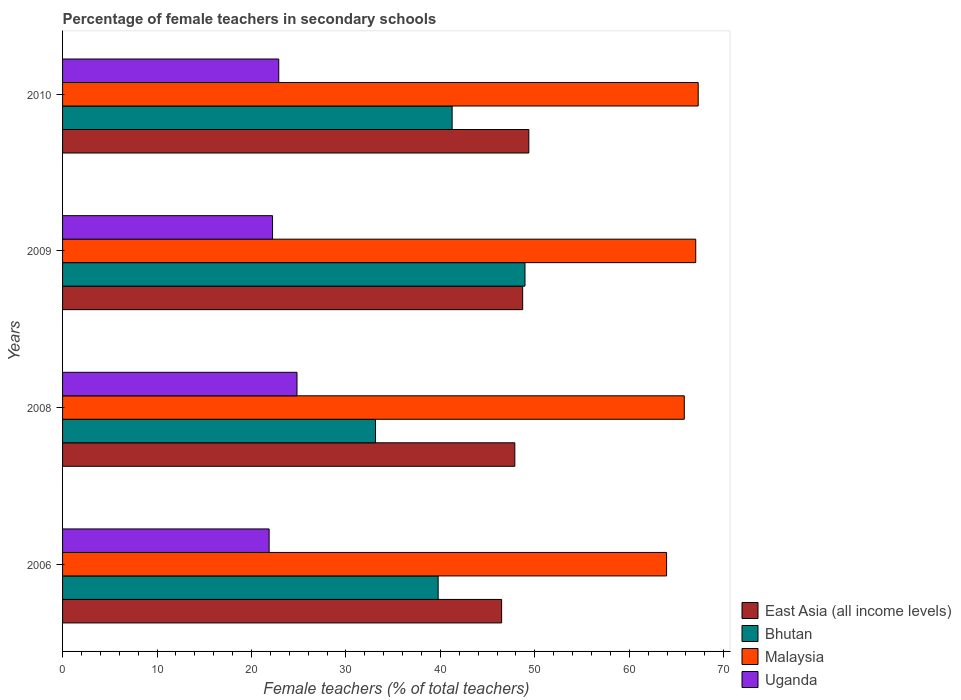Are the number of bars on each tick of the Y-axis equal?
Keep it short and to the point. Yes. What is the label of the 4th group of bars from the top?
Your response must be concise. 2006. What is the percentage of female teachers in Bhutan in 2006?
Provide a short and direct response. 39.77. Across all years, what is the maximum percentage of female teachers in East Asia (all income levels)?
Offer a terse response. 49.37. Across all years, what is the minimum percentage of female teachers in Malaysia?
Your answer should be compact. 63.95. In which year was the percentage of female teachers in Bhutan minimum?
Make the answer very short. 2008. What is the total percentage of female teachers in Bhutan in the graph?
Your answer should be very brief. 163.11. What is the difference between the percentage of female teachers in Bhutan in 2009 and that in 2010?
Provide a short and direct response. 7.71. What is the difference between the percentage of female teachers in Uganda in 2006 and the percentage of female teachers in Bhutan in 2008?
Provide a short and direct response. -11.27. What is the average percentage of female teachers in Bhutan per year?
Give a very brief answer. 40.78. In the year 2008, what is the difference between the percentage of female teachers in East Asia (all income levels) and percentage of female teachers in Bhutan?
Your answer should be compact. 14.75. In how many years, is the percentage of female teachers in Bhutan greater than 2 %?
Your answer should be compact. 4. What is the ratio of the percentage of female teachers in Uganda in 2006 to that in 2010?
Your answer should be compact. 0.96. What is the difference between the highest and the second highest percentage of female teachers in Malaysia?
Offer a terse response. 0.26. What is the difference between the highest and the lowest percentage of female teachers in Bhutan?
Your response must be concise. 15.82. In how many years, is the percentage of female teachers in Uganda greater than the average percentage of female teachers in Uganda taken over all years?
Your answer should be very brief. 1. What does the 4th bar from the top in 2010 represents?
Your answer should be compact. East Asia (all income levels). What does the 2nd bar from the bottom in 2006 represents?
Provide a succinct answer. Bhutan. Is it the case that in every year, the sum of the percentage of female teachers in Malaysia and percentage of female teachers in Uganda is greater than the percentage of female teachers in East Asia (all income levels)?
Provide a succinct answer. Yes. How many bars are there?
Your answer should be very brief. 16. How many years are there in the graph?
Your answer should be very brief. 4. Does the graph contain grids?
Provide a succinct answer. No. Where does the legend appear in the graph?
Keep it short and to the point. Bottom right. How are the legend labels stacked?
Provide a short and direct response. Vertical. What is the title of the graph?
Make the answer very short. Percentage of female teachers in secondary schools. Does "Japan" appear as one of the legend labels in the graph?
Ensure brevity in your answer.  No. What is the label or title of the X-axis?
Your answer should be very brief. Female teachers (% of total teachers). What is the label or title of the Y-axis?
Your response must be concise. Years. What is the Female teachers (% of total teachers) in East Asia (all income levels) in 2006?
Provide a succinct answer. 46.49. What is the Female teachers (% of total teachers) in Bhutan in 2006?
Your answer should be compact. 39.77. What is the Female teachers (% of total teachers) of Malaysia in 2006?
Your response must be concise. 63.95. What is the Female teachers (% of total teachers) in Uganda in 2006?
Offer a terse response. 21.87. What is the Female teachers (% of total teachers) of East Asia (all income levels) in 2008?
Make the answer very short. 47.88. What is the Female teachers (% of total teachers) in Bhutan in 2008?
Your response must be concise. 33.14. What is the Female teachers (% of total teachers) in Malaysia in 2008?
Make the answer very short. 65.83. What is the Female teachers (% of total teachers) of Uganda in 2008?
Offer a very short reply. 24.82. What is the Female teachers (% of total teachers) of East Asia (all income levels) in 2009?
Your response must be concise. 48.71. What is the Female teachers (% of total teachers) of Bhutan in 2009?
Give a very brief answer. 48.96. What is the Female teachers (% of total teachers) in Malaysia in 2009?
Ensure brevity in your answer.  67.04. What is the Female teachers (% of total teachers) in Uganda in 2009?
Provide a short and direct response. 22.23. What is the Female teachers (% of total teachers) in East Asia (all income levels) in 2010?
Your answer should be compact. 49.37. What is the Female teachers (% of total teachers) in Bhutan in 2010?
Offer a terse response. 41.25. What is the Female teachers (% of total teachers) in Malaysia in 2010?
Provide a short and direct response. 67.3. What is the Female teachers (% of total teachers) in Uganda in 2010?
Your answer should be compact. 22.89. Across all years, what is the maximum Female teachers (% of total teachers) in East Asia (all income levels)?
Keep it short and to the point. 49.37. Across all years, what is the maximum Female teachers (% of total teachers) of Bhutan?
Keep it short and to the point. 48.96. Across all years, what is the maximum Female teachers (% of total teachers) of Malaysia?
Give a very brief answer. 67.3. Across all years, what is the maximum Female teachers (% of total teachers) in Uganda?
Provide a short and direct response. 24.82. Across all years, what is the minimum Female teachers (% of total teachers) of East Asia (all income levels)?
Your answer should be compact. 46.49. Across all years, what is the minimum Female teachers (% of total teachers) of Bhutan?
Give a very brief answer. 33.14. Across all years, what is the minimum Female teachers (% of total teachers) of Malaysia?
Your answer should be compact. 63.95. Across all years, what is the minimum Female teachers (% of total teachers) in Uganda?
Provide a short and direct response. 21.87. What is the total Female teachers (% of total teachers) in East Asia (all income levels) in the graph?
Your answer should be compact. 192.45. What is the total Female teachers (% of total teachers) in Bhutan in the graph?
Offer a very short reply. 163.11. What is the total Female teachers (% of total teachers) of Malaysia in the graph?
Your answer should be compact. 264.12. What is the total Female teachers (% of total teachers) in Uganda in the graph?
Your answer should be very brief. 91.81. What is the difference between the Female teachers (% of total teachers) in East Asia (all income levels) in 2006 and that in 2008?
Keep it short and to the point. -1.4. What is the difference between the Female teachers (% of total teachers) in Bhutan in 2006 and that in 2008?
Keep it short and to the point. 6.63. What is the difference between the Female teachers (% of total teachers) of Malaysia in 2006 and that in 2008?
Make the answer very short. -1.87. What is the difference between the Female teachers (% of total teachers) in Uganda in 2006 and that in 2008?
Ensure brevity in your answer.  -2.95. What is the difference between the Female teachers (% of total teachers) in East Asia (all income levels) in 2006 and that in 2009?
Ensure brevity in your answer.  -2.23. What is the difference between the Female teachers (% of total teachers) in Bhutan in 2006 and that in 2009?
Provide a succinct answer. -9.19. What is the difference between the Female teachers (% of total teachers) in Malaysia in 2006 and that in 2009?
Provide a succinct answer. -3.09. What is the difference between the Female teachers (% of total teachers) in Uganda in 2006 and that in 2009?
Provide a succinct answer. -0.36. What is the difference between the Female teachers (% of total teachers) in East Asia (all income levels) in 2006 and that in 2010?
Offer a terse response. -2.88. What is the difference between the Female teachers (% of total teachers) of Bhutan in 2006 and that in 2010?
Ensure brevity in your answer.  -1.48. What is the difference between the Female teachers (% of total teachers) of Malaysia in 2006 and that in 2010?
Give a very brief answer. -3.35. What is the difference between the Female teachers (% of total teachers) of Uganda in 2006 and that in 2010?
Give a very brief answer. -1.02. What is the difference between the Female teachers (% of total teachers) of East Asia (all income levels) in 2008 and that in 2009?
Provide a short and direct response. -0.83. What is the difference between the Female teachers (% of total teachers) of Bhutan in 2008 and that in 2009?
Provide a short and direct response. -15.82. What is the difference between the Female teachers (% of total teachers) in Malaysia in 2008 and that in 2009?
Provide a succinct answer. -1.21. What is the difference between the Female teachers (% of total teachers) of Uganda in 2008 and that in 2009?
Your answer should be very brief. 2.59. What is the difference between the Female teachers (% of total teachers) in East Asia (all income levels) in 2008 and that in 2010?
Ensure brevity in your answer.  -1.48. What is the difference between the Female teachers (% of total teachers) of Bhutan in 2008 and that in 2010?
Your answer should be very brief. -8.11. What is the difference between the Female teachers (% of total teachers) of Malaysia in 2008 and that in 2010?
Offer a terse response. -1.47. What is the difference between the Female teachers (% of total teachers) of Uganda in 2008 and that in 2010?
Your answer should be compact. 1.93. What is the difference between the Female teachers (% of total teachers) in East Asia (all income levels) in 2009 and that in 2010?
Offer a very short reply. -0.65. What is the difference between the Female teachers (% of total teachers) in Bhutan in 2009 and that in 2010?
Provide a succinct answer. 7.71. What is the difference between the Female teachers (% of total teachers) of Malaysia in 2009 and that in 2010?
Ensure brevity in your answer.  -0.26. What is the difference between the Female teachers (% of total teachers) in Uganda in 2009 and that in 2010?
Offer a very short reply. -0.66. What is the difference between the Female teachers (% of total teachers) of East Asia (all income levels) in 2006 and the Female teachers (% of total teachers) of Bhutan in 2008?
Ensure brevity in your answer.  13.35. What is the difference between the Female teachers (% of total teachers) in East Asia (all income levels) in 2006 and the Female teachers (% of total teachers) in Malaysia in 2008?
Make the answer very short. -19.34. What is the difference between the Female teachers (% of total teachers) of East Asia (all income levels) in 2006 and the Female teachers (% of total teachers) of Uganda in 2008?
Your response must be concise. 21.67. What is the difference between the Female teachers (% of total teachers) in Bhutan in 2006 and the Female teachers (% of total teachers) in Malaysia in 2008?
Offer a very short reply. -26.06. What is the difference between the Female teachers (% of total teachers) of Bhutan in 2006 and the Female teachers (% of total teachers) of Uganda in 2008?
Give a very brief answer. 14.95. What is the difference between the Female teachers (% of total teachers) of Malaysia in 2006 and the Female teachers (% of total teachers) of Uganda in 2008?
Your response must be concise. 39.13. What is the difference between the Female teachers (% of total teachers) in East Asia (all income levels) in 2006 and the Female teachers (% of total teachers) in Bhutan in 2009?
Provide a short and direct response. -2.47. What is the difference between the Female teachers (% of total teachers) of East Asia (all income levels) in 2006 and the Female teachers (% of total teachers) of Malaysia in 2009?
Offer a very short reply. -20.55. What is the difference between the Female teachers (% of total teachers) in East Asia (all income levels) in 2006 and the Female teachers (% of total teachers) in Uganda in 2009?
Your answer should be very brief. 24.25. What is the difference between the Female teachers (% of total teachers) in Bhutan in 2006 and the Female teachers (% of total teachers) in Malaysia in 2009?
Keep it short and to the point. -27.27. What is the difference between the Female teachers (% of total teachers) of Bhutan in 2006 and the Female teachers (% of total teachers) of Uganda in 2009?
Your response must be concise. 17.53. What is the difference between the Female teachers (% of total teachers) of Malaysia in 2006 and the Female teachers (% of total teachers) of Uganda in 2009?
Make the answer very short. 41.72. What is the difference between the Female teachers (% of total teachers) in East Asia (all income levels) in 2006 and the Female teachers (% of total teachers) in Bhutan in 2010?
Ensure brevity in your answer.  5.24. What is the difference between the Female teachers (% of total teachers) of East Asia (all income levels) in 2006 and the Female teachers (% of total teachers) of Malaysia in 2010?
Keep it short and to the point. -20.81. What is the difference between the Female teachers (% of total teachers) of East Asia (all income levels) in 2006 and the Female teachers (% of total teachers) of Uganda in 2010?
Keep it short and to the point. 23.6. What is the difference between the Female teachers (% of total teachers) of Bhutan in 2006 and the Female teachers (% of total teachers) of Malaysia in 2010?
Offer a very short reply. -27.53. What is the difference between the Female teachers (% of total teachers) in Bhutan in 2006 and the Female teachers (% of total teachers) in Uganda in 2010?
Your answer should be compact. 16.88. What is the difference between the Female teachers (% of total teachers) in Malaysia in 2006 and the Female teachers (% of total teachers) in Uganda in 2010?
Offer a very short reply. 41.06. What is the difference between the Female teachers (% of total teachers) of East Asia (all income levels) in 2008 and the Female teachers (% of total teachers) of Bhutan in 2009?
Your answer should be very brief. -1.08. What is the difference between the Female teachers (% of total teachers) of East Asia (all income levels) in 2008 and the Female teachers (% of total teachers) of Malaysia in 2009?
Give a very brief answer. -19.15. What is the difference between the Female teachers (% of total teachers) in East Asia (all income levels) in 2008 and the Female teachers (% of total teachers) in Uganda in 2009?
Your response must be concise. 25.65. What is the difference between the Female teachers (% of total teachers) in Bhutan in 2008 and the Female teachers (% of total teachers) in Malaysia in 2009?
Ensure brevity in your answer.  -33.9. What is the difference between the Female teachers (% of total teachers) in Bhutan in 2008 and the Female teachers (% of total teachers) in Uganda in 2009?
Your answer should be compact. 10.9. What is the difference between the Female teachers (% of total teachers) in Malaysia in 2008 and the Female teachers (% of total teachers) in Uganda in 2009?
Your answer should be very brief. 43.59. What is the difference between the Female teachers (% of total teachers) in East Asia (all income levels) in 2008 and the Female teachers (% of total teachers) in Bhutan in 2010?
Offer a very short reply. 6.64. What is the difference between the Female teachers (% of total teachers) of East Asia (all income levels) in 2008 and the Female teachers (% of total teachers) of Malaysia in 2010?
Give a very brief answer. -19.42. What is the difference between the Female teachers (% of total teachers) in East Asia (all income levels) in 2008 and the Female teachers (% of total teachers) in Uganda in 2010?
Offer a very short reply. 24.99. What is the difference between the Female teachers (% of total teachers) in Bhutan in 2008 and the Female teachers (% of total teachers) in Malaysia in 2010?
Make the answer very short. -34.16. What is the difference between the Female teachers (% of total teachers) of Bhutan in 2008 and the Female teachers (% of total teachers) of Uganda in 2010?
Your answer should be compact. 10.25. What is the difference between the Female teachers (% of total teachers) in Malaysia in 2008 and the Female teachers (% of total teachers) in Uganda in 2010?
Offer a very short reply. 42.94. What is the difference between the Female teachers (% of total teachers) in East Asia (all income levels) in 2009 and the Female teachers (% of total teachers) in Bhutan in 2010?
Provide a succinct answer. 7.47. What is the difference between the Female teachers (% of total teachers) in East Asia (all income levels) in 2009 and the Female teachers (% of total teachers) in Malaysia in 2010?
Offer a very short reply. -18.59. What is the difference between the Female teachers (% of total teachers) of East Asia (all income levels) in 2009 and the Female teachers (% of total teachers) of Uganda in 2010?
Your answer should be compact. 25.82. What is the difference between the Female teachers (% of total teachers) of Bhutan in 2009 and the Female teachers (% of total teachers) of Malaysia in 2010?
Give a very brief answer. -18.34. What is the difference between the Female teachers (% of total teachers) of Bhutan in 2009 and the Female teachers (% of total teachers) of Uganda in 2010?
Offer a terse response. 26.07. What is the difference between the Female teachers (% of total teachers) in Malaysia in 2009 and the Female teachers (% of total teachers) in Uganda in 2010?
Make the answer very short. 44.15. What is the average Female teachers (% of total teachers) in East Asia (all income levels) per year?
Offer a terse response. 48.11. What is the average Female teachers (% of total teachers) in Bhutan per year?
Give a very brief answer. 40.78. What is the average Female teachers (% of total teachers) of Malaysia per year?
Your answer should be compact. 66.03. What is the average Female teachers (% of total teachers) in Uganda per year?
Your answer should be compact. 22.95. In the year 2006, what is the difference between the Female teachers (% of total teachers) in East Asia (all income levels) and Female teachers (% of total teachers) in Bhutan?
Make the answer very short. 6.72. In the year 2006, what is the difference between the Female teachers (% of total teachers) of East Asia (all income levels) and Female teachers (% of total teachers) of Malaysia?
Give a very brief answer. -17.46. In the year 2006, what is the difference between the Female teachers (% of total teachers) of East Asia (all income levels) and Female teachers (% of total teachers) of Uganda?
Your answer should be compact. 24.62. In the year 2006, what is the difference between the Female teachers (% of total teachers) in Bhutan and Female teachers (% of total teachers) in Malaysia?
Your answer should be compact. -24.18. In the year 2006, what is the difference between the Female teachers (% of total teachers) in Bhutan and Female teachers (% of total teachers) in Uganda?
Your answer should be compact. 17.9. In the year 2006, what is the difference between the Female teachers (% of total teachers) in Malaysia and Female teachers (% of total teachers) in Uganda?
Offer a terse response. 42.08. In the year 2008, what is the difference between the Female teachers (% of total teachers) in East Asia (all income levels) and Female teachers (% of total teachers) in Bhutan?
Offer a terse response. 14.75. In the year 2008, what is the difference between the Female teachers (% of total teachers) in East Asia (all income levels) and Female teachers (% of total teachers) in Malaysia?
Provide a succinct answer. -17.94. In the year 2008, what is the difference between the Female teachers (% of total teachers) of East Asia (all income levels) and Female teachers (% of total teachers) of Uganda?
Offer a terse response. 23.06. In the year 2008, what is the difference between the Female teachers (% of total teachers) in Bhutan and Female teachers (% of total teachers) in Malaysia?
Your answer should be compact. -32.69. In the year 2008, what is the difference between the Female teachers (% of total teachers) in Bhutan and Female teachers (% of total teachers) in Uganda?
Your response must be concise. 8.31. In the year 2008, what is the difference between the Female teachers (% of total teachers) of Malaysia and Female teachers (% of total teachers) of Uganda?
Keep it short and to the point. 41.01. In the year 2009, what is the difference between the Female teachers (% of total teachers) in East Asia (all income levels) and Female teachers (% of total teachers) in Bhutan?
Give a very brief answer. -0.24. In the year 2009, what is the difference between the Female teachers (% of total teachers) of East Asia (all income levels) and Female teachers (% of total teachers) of Malaysia?
Offer a terse response. -18.32. In the year 2009, what is the difference between the Female teachers (% of total teachers) in East Asia (all income levels) and Female teachers (% of total teachers) in Uganda?
Offer a very short reply. 26.48. In the year 2009, what is the difference between the Female teachers (% of total teachers) in Bhutan and Female teachers (% of total teachers) in Malaysia?
Keep it short and to the point. -18.08. In the year 2009, what is the difference between the Female teachers (% of total teachers) in Bhutan and Female teachers (% of total teachers) in Uganda?
Your response must be concise. 26.73. In the year 2009, what is the difference between the Female teachers (% of total teachers) in Malaysia and Female teachers (% of total teachers) in Uganda?
Provide a succinct answer. 44.81. In the year 2010, what is the difference between the Female teachers (% of total teachers) of East Asia (all income levels) and Female teachers (% of total teachers) of Bhutan?
Ensure brevity in your answer.  8.12. In the year 2010, what is the difference between the Female teachers (% of total teachers) of East Asia (all income levels) and Female teachers (% of total teachers) of Malaysia?
Give a very brief answer. -17.93. In the year 2010, what is the difference between the Female teachers (% of total teachers) in East Asia (all income levels) and Female teachers (% of total teachers) in Uganda?
Ensure brevity in your answer.  26.48. In the year 2010, what is the difference between the Female teachers (% of total teachers) in Bhutan and Female teachers (% of total teachers) in Malaysia?
Ensure brevity in your answer.  -26.05. In the year 2010, what is the difference between the Female teachers (% of total teachers) in Bhutan and Female teachers (% of total teachers) in Uganda?
Offer a very short reply. 18.36. In the year 2010, what is the difference between the Female teachers (% of total teachers) of Malaysia and Female teachers (% of total teachers) of Uganda?
Provide a succinct answer. 44.41. What is the ratio of the Female teachers (% of total teachers) of East Asia (all income levels) in 2006 to that in 2008?
Provide a succinct answer. 0.97. What is the ratio of the Female teachers (% of total teachers) of Bhutan in 2006 to that in 2008?
Make the answer very short. 1.2. What is the ratio of the Female teachers (% of total teachers) in Malaysia in 2006 to that in 2008?
Your answer should be compact. 0.97. What is the ratio of the Female teachers (% of total teachers) of Uganda in 2006 to that in 2008?
Offer a very short reply. 0.88. What is the ratio of the Female teachers (% of total teachers) of East Asia (all income levels) in 2006 to that in 2009?
Offer a very short reply. 0.95. What is the ratio of the Female teachers (% of total teachers) of Bhutan in 2006 to that in 2009?
Offer a very short reply. 0.81. What is the ratio of the Female teachers (% of total teachers) in Malaysia in 2006 to that in 2009?
Your answer should be compact. 0.95. What is the ratio of the Female teachers (% of total teachers) of Uganda in 2006 to that in 2009?
Your response must be concise. 0.98. What is the ratio of the Female teachers (% of total teachers) of East Asia (all income levels) in 2006 to that in 2010?
Your response must be concise. 0.94. What is the ratio of the Female teachers (% of total teachers) of Bhutan in 2006 to that in 2010?
Your response must be concise. 0.96. What is the ratio of the Female teachers (% of total teachers) in Malaysia in 2006 to that in 2010?
Your response must be concise. 0.95. What is the ratio of the Female teachers (% of total teachers) of Uganda in 2006 to that in 2010?
Your answer should be compact. 0.96. What is the ratio of the Female teachers (% of total teachers) in Bhutan in 2008 to that in 2009?
Ensure brevity in your answer.  0.68. What is the ratio of the Female teachers (% of total teachers) in Malaysia in 2008 to that in 2009?
Give a very brief answer. 0.98. What is the ratio of the Female teachers (% of total teachers) of Uganda in 2008 to that in 2009?
Keep it short and to the point. 1.12. What is the ratio of the Female teachers (% of total teachers) in Bhutan in 2008 to that in 2010?
Give a very brief answer. 0.8. What is the ratio of the Female teachers (% of total teachers) in Malaysia in 2008 to that in 2010?
Give a very brief answer. 0.98. What is the ratio of the Female teachers (% of total teachers) in Uganda in 2008 to that in 2010?
Offer a terse response. 1.08. What is the ratio of the Female teachers (% of total teachers) in Bhutan in 2009 to that in 2010?
Give a very brief answer. 1.19. What is the ratio of the Female teachers (% of total teachers) of Malaysia in 2009 to that in 2010?
Give a very brief answer. 1. What is the ratio of the Female teachers (% of total teachers) in Uganda in 2009 to that in 2010?
Ensure brevity in your answer.  0.97. What is the difference between the highest and the second highest Female teachers (% of total teachers) of East Asia (all income levels)?
Provide a short and direct response. 0.65. What is the difference between the highest and the second highest Female teachers (% of total teachers) in Bhutan?
Your answer should be very brief. 7.71. What is the difference between the highest and the second highest Female teachers (% of total teachers) in Malaysia?
Your response must be concise. 0.26. What is the difference between the highest and the second highest Female teachers (% of total teachers) in Uganda?
Offer a very short reply. 1.93. What is the difference between the highest and the lowest Female teachers (% of total teachers) in East Asia (all income levels)?
Your answer should be compact. 2.88. What is the difference between the highest and the lowest Female teachers (% of total teachers) of Bhutan?
Provide a succinct answer. 15.82. What is the difference between the highest and the lowest Female teachers (% of total teachers) in Malaysia?
Ensure brevity in your answer.  3.35. What is the difference between the highest and the lowest Female teachers (% of total teachers) in Uganda?
Your answer should be very brief. 2.95. 